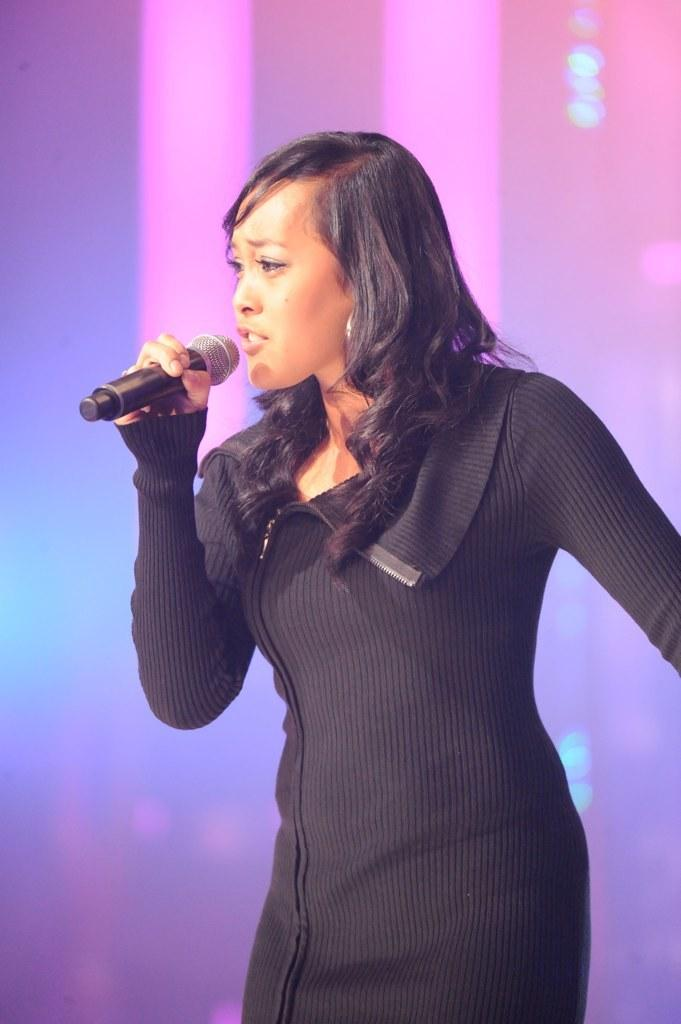Who is the main subject in the image? There is a woman in the image. What is the woman doing in the image? The woman is singing. What objects are present in the image that might be related to the woman's activity? There are microphones in the image. What is the woman wearing in the image? The woman is wearing a black dress. How does the woman compare her performance to the previous loss in the image? There is no mention of a loss or comparison in the image; it simply shows a woman singing with microphones present. 